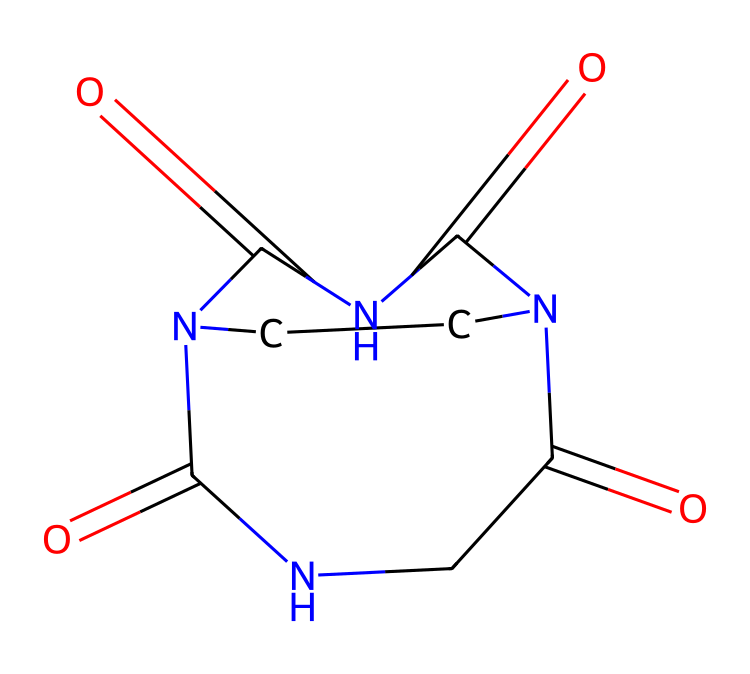What is the number of nitrogen atoms in this compound? By examining the SMILES representation, I can identify that there are two "N" atoms present, indicating that there are two nitrogen atoms in total within the structure.
Answer: two How many carbon atoms are in the structure? The SMILES representation includes the letter "C" indicating carbon atoms. Upon counting, there are four "C" atoms, which confirms that there are four carbon atoms in this compound.
Answer: four What type of bonds connect the carbon and nitrogen atoms? Analyzing the structure shows that carbon and nitrogen are involved in multiple bonds, both single and double bonds. Specifically, there are double bonds indicated by the "=" sign in the SMILES notation.
Answer: single and double What is the molecular formula of the compound? Counting the elements from the structure, I find two nitrogen atoms (N), four carbon atoms (C), and additional oxygen atoms contribute to the final formula, leading to the molecular formula being derived as C4N4O2.
Answer: C4N4O2 Is this compound cyclic or acyclic? Examining the structure, I notice that there are connections that create enclosed rings among atoms, indicating that it is structured as a cyclic compound.
Answer: cyclic What applications could this compound have in drug delivery? Considering that cage compounds like this have applications as carriers for drugs, I recognize that their ability to form stable structures can encapsulate drugs and facilitate controlled release in biological systems.
Answer: drug carrier Which specific type of cage compound is represented here? Evaluating the structure, it mirrors the characteristic features of cucurbit[n]urils known for their barrel-shaped geometry and potential applications in drug encapsulation and catalysis.
Answer: cucurbit[n]uril 